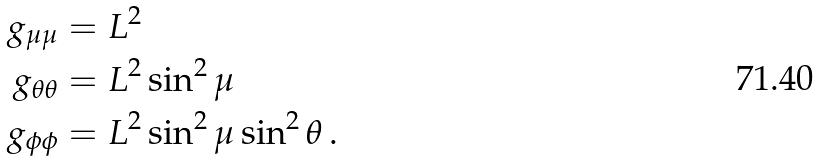<formula> <loc_0><loc_0><loc_500><loc_500>g _ { \mu \mu } & = L ^ { 2 } \\ g _ { \theta \theta } & = L ^ { 2 } \sin ^ { 2 } \mu \\ g _ { \phi \phi } & = L ^ { 2 } \sin ^ { 2 } \mu \sin ^ { 2 } \theta \, .</formula> 